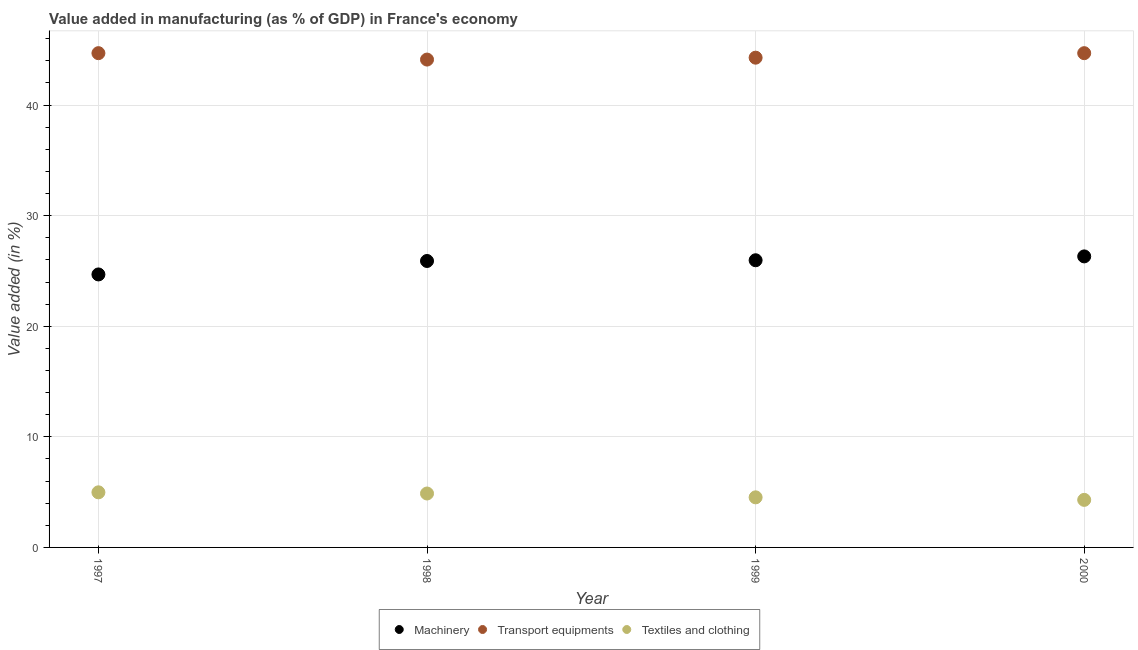How many different coloured dotlines are there?
Your answer should be very brief. 3. Is the number of dotlines equal to the number of legend labels?
Provide a short and direct response. Yes. What is the value added in manufacturing textile and clothing in 1997?
Ensure brevity in your answer.  4.98. Across all years, what is the maximum value added in manufacturing textile and clothing?
Provide a short and direct response. 4.98. Across all years, what is the minimum value added in manufacturing transport equipments?
Provide a succinct answer. 44.12. In which year was the value added in manufacturing textile and clothing maximum?
Keep it short and to the point. 1997. In which year was the value added in manufacturing machinery minimum?
Keep it short and to the point. 1997. What is the total value added in manufacturing textile and clothing in the graph?
Offer a very short reply. 18.69. What is the difference between the value added in manufacturing transport equipments in 1997 and that in 1998?
Make the answer very short. 0.58. What is the difference between the value added in manufacturing transport equipments in 1998 and the value added in manufacturing machinery in 2000?
Provide a short and direct response. 17.8. What is the average value added in manufacturing machinery per year?
Your answer should be very brief. 25.72. In the year 1999, what is the difference between the value added in manufacturing transport equipments and value added in manufacturing textile and clothing?
Give a very brief answer. 39.76. What is the ratio of the value added in manufacturing textile and clothing in 1997 to that in 2000?
Offer a terse response. 1.16. Is the difference between the value added in manufacturing machinery in 1999 and 2000 greater than the difference between the value added in manufacturing textile and clothing in 1999 and 2000?
Provide a short and direct response. No. What is the difference between the highest and the second highest value added in manufacturing textile and clothing?
Offer a terse response. 0.11. What is the difference between the highest and the lowest value added in manufacturing textile and clothing?
Keep it short and to the point. 0.68. In how many years, is the value added in manufacturing transport equipments greater than the average value added in manufacturing transport equipments taken over all years?
Keep it short and to the point. 2. Is the sum of the value added in manufacturing transport equipments in 1998 and 1999 greater than the maximum value added in manufacturing textile and clothing across all years?
Your response must be concise. Yes. Does the value added in manufacturing transport equipments monotonically increase over the years?
Make the answer very short. No. Is the value added in manufacturing machinery strictly greater than the value added in manufacturing transport equipments over the years?
Ensure brevity in your answer.  No. How many dotlines are there?
Give a very brief answer. 3. How many years are there in the graph?
Offer a very short reply. 4. What is the difference between two consecutive major ticks on the Y-axis?
Ensure brevity in your answer.  10. How are the legend labels stacked?
Your answer should be very brief. Horizontal. What is the title of the graph?
Provide a succinct answer. Value added in manufacturing (as % of GDP) in France's economy. What is the label or title of the X-axis?
Provide a short and direct response. Year. What is the label or title of the Y-axis?
Keep it short and to the point. Value added (in %). What is the Value added (in %) in Machinery in 1997?
Your answer should be compact. 24.69. What is the Value added (in %) of Transport equipments in 1997?
Ensure brevity in your answer.  44.7. What is the Value added (in %) of Textiles and clothing in 1997?
Keep it short and to the point. 4.98. What is the Value added (in %) in Machinery in 1998?
Give a very brief answer. 25.9. What is the Value added (in %) in Transport equipments in 1998?
Provide a short and direct response. 44.12. What is the Value added (in %) of Textiles and clothing in 1998?
Give a very brief answer. 4.88. What is the Value added (in %) in Machinery in 1999?
Your response must be concise. 25.97. What is the Value added (in %) in Transport equipments in 1999?
Provide a short and direct response. 44.29. What is the Value added (in %) in Textiles and clothing in 1999?
Your answer should be compact. 4.53. What is the Value added (in %) in Machinery in 2000?
Provide a succinct answer. 26.32. What is the Value added (in %) of Transport equipments in 2000?
Provide a short and direct response. 44.7. What is the Value added (in %) in Textiles and clothing in 2000?
Provide a short and direct response. 4.3. Across all years, what is the maximum Value added (in %) of Machinery?
Your answer should be very brief. 26.32. Across all years, what is the maximum Value added (in %) in Transport equipments?
Offer a terse response. 44.7. Across all years, what is the maximum Value added (in %) in Textiles and clothing?
Offer a terse response. 4.98. Across all years, what is the minimum Value added (in %) of Machinery?
Your answer should be compact. 24.69. Across all years, what is the minimum Value added (in %) in Transport equipments?
Ensure brevity in your answer.  44.12. Across all years, what is the minimum Value added (in %) of Textiles and clothing?
Make the answer very short. 4.3. What is the total Value added (in %) in Machinery in the graph?
Your answer should be compact. 102.88. What is the total Value added (in %) in Transport equipments in the graph?
Provide a short and direct response. 177.8. What is the total Value added (in %) of Textiles and clothing in the graph?
Your answer should be compact. 18.69. What is the difference between the Value added (in %) in Machinery in 1997 and that in 1998?
Offer a terse response. -1.22. What is the difference between the Value added (in %) of Transport equipments in 1997 and that in 1998?
Make the answer very short. 0.58. What is the difference between the Value added (in %) of Textiles and clothing in 1997 and that in 1998?
Offer a very short reply. 0.11. What is the difference between the Value added (in %) in Machinery in 1997 and that in 1999?
Your answer should be very brief. -1.28. What is the difference between the Value added (in %) in Transport equipments in 1997 and that in 1999?
Keep it short and to the point. 0.41. What is the difference between the Value added (in %) of Textiles and clothing in 1997 and that in 1999?
Provide a short and direct response. 0.45. What is the difference between the Value added (in %) in Machinery in 1997 and that in 2000?
Your answer should be compact. -1.63. What is the difference between the Value added (in %) of Transport equipments in 1997 and that in 2000?
Offer a very short reply. 0. What is the difference between the Value added (in %) in Textiles and clothing in 1997 and that in 2000?
Offer a very short reply. 0.68. What is the difference between the Value added (in %) in Machinery in 1998 and that in 1999?
Your answer should be very brief. -0.07. What is the difference between the Value added (in %) in Transport equipments in 1998 and that in 1999?
Provide a short and direct response. -0.17. What is the difference between the Value added (in %) in Textiles and clothing in 1998 and that in 1999?
Your answer should be very brief. 0.35. What is the difference between the Value added (in %) in Machinery in 1998 and that in 2000?
Offer a terse response. -0.41. What is the difference between the Value added (in %) in Transport equipments in 1998 and that in 2000?
Ensure brevity in your answer.  -0.58. What is the difference between the Value added (in %) in Textiles and clothing in 1998 and that in 2000?
Offer a terse response. 0.58. What is the difference between the Value added (in %) in Machinery in 1999 and that in 2000?
Ensure brevity in your answer.  -0.35. What is the difference between the Value added (in %) of Transport equipments in 1999 and that in 2000?
Your response must be concise. -0.41. What is the difference between the Value added (in %) in Textiles and clothing in 1999 and that in 2000?
Keep it short and to the point. 0.23. What is the difference between the Value added (in %) of Machinery in 1997 and the Value added (in %) of Transport equipments in 1998?
Keep it short and to the point. -19.43. What is the difference between the Value added (in %) of Machinery in 1997 and the Value added (in %) of Textiles and clothing in 1998?
Make the answer very short. 19.81. What is the difference between the Value added (in %) of Transport equipments in 1997 and the Value added (in %) of Textiles and clothing in 1998?
Ensure brevity in your answer.  39.82. What is the difference between the Value added (in %) in Machinery in 1997 and the Value added (in %) in Transport equipments in 1999?
Offer a terse response. -19.6. What is the difference between the Value added (in %) in Machinery in 1997 and the Value added (in %) in Textiles and clothing in 1999?
Your response must be concise. 20.16. What is the difference between the Value added (in %) in Transport equipments in 1997 and the Value added (in %) in Textiles and clothing in 1999?
Your response must be concise. 40.17. What is the difference between the Value added (in %) of Machinery in 1997 and the Value added (in %) of Transport equipments in 2000?
Offer a terse response. -20.01. What is the difference between the Value added (in %) of Machinery in 1997 and the Value added (in %) of Textiles and clothing in 2000?
Keep it short and to the point. 20.39. What is the difference between the Value added (in %) in Transport equipments in 1997 and the Value added (in %) in Textiles and clothing in 2000?
Provide a short and direct response. 40.4. What is the difference between the Value added (in %) of Machinery in 1998 and the Value added (in %) of Transport equipments in 1999?
Keep it short and to the point. -18.39. What is the difference between the Value added (in %) of Machinery in 1998 and the Value added (in %) of Textiles and clothing in 1999?
Give a very brief answer. 21.37. What is the difference between the Value added (in %) of Transport equipments in 1998 and the Value added (in %) of Textiles and clothing in 1999?
Provide a short and direct response. 39.59. What is the difference between the Value added (in %) of Machinery in 1998 and the Value added (in %) of Transport equipments in 2000?
Your answer should be compact. -18.79. What is the difference between the Value added (in %) of Machinery in 1998 and the Value added (in %) of Textiles and clothing in 2000?
Give a very brief answer. 21.6. What is the difference between the Value added (in %) of Transport equipments in 1998 and the Value added (in %) of Textiles and clothing in 2000?
Give a very brief answer. 39.82. What is the difference between the Value added (in %) of Machinery in 1999 and the Value added (in %) of Transport equipments in 2000?
Offer a terse response. -18.73. What is the difference between the Value added (in %) of Machinery in 1999 and the Value added (in %) of Textiles and clothing in 2000?
Provide a succinct answer. 21.67. What is the difference between the Value added (in %) of Transport equipments in 1999 and the Value added (in %) of Textiles and clothing in 2000?
Provide a short and direct response. 39.99. What is the average Value added (in %) in Machinery per year?
Provide a short and direct response. 25.72. What is the average Value added (in %) of Transport equipments per year?
Provide a succinct answer. 44.45. What is the average Value added (in %) of Textiles and clothing per year?
Keep it short and to the point. 4.67. In the year 1997, what is the difference between the Value added (in %) in Machinery and Value added (in %) in Transport equipments?
Your answer should be very brief. -20.01. In the year 1997, what is the difference between the Value added (in %) in Machinery and Value added (in %) in Textiles and clothing?
Ensure brevity in your answer.  19.7. In the year 1997, what is the difference between the Value added (in %) in Transport equipments and Value added (in %) in Textiles and clothing?
Ensure brevity in your answer.  39.71. In the year 1998, what is the difference between the Value added (in %) in Machinery and Value added (in %) in Transport equipments?
Give a very brief answer. -18.21. In the year 1998, what is the difference between the Value added (in %) of Machinery and Value added (in %) of Textiles and clothing?
Give a very brief answer. 21.03. In the year 1998, what is the difference between the Value added (in %) in Transport equipments and Value added (in %) in Textiles and clothing?
Provide a short and direct response. 39.24. In the year 1999, what is the difference between the Value added (in %) of Machinery and Value added (in %) of Transport equipments?
Give a very brief answer. -18.32. In the year 1999, what is the difference between the Value added (in %) of Machinery and Value added (in %) of Textiles and clothing?
Offer a very short reply. 21.44. In the year 1999, what is the difference between the Value added (in %) in Transport equipments and Value added (in %) in Textiles and clothing?
Provide a short and direct response. 39.76. In the year 2000, what is the difference between the Value added (in %) in Machinery and Value added (in %) in Transport equipments?
Give a very brief answer. -18.38. In the year 2000, what is the difference between the Value added (in %) of Machinery and Value added (in %) of Textiles and clothing?
Provide a short and direct response. 22.02. In the year 2000, what is the difference between the Value added (in %) in Transport equipments and Value added (in %) in Textiles and clothing?
Keep it short and to the point. 40.4. What is the ratio of the Value added (in %) in Machinery in 1997 to that in 1998?
Offer a terse response. 0.95. What is the ratio of the Value added (in %) in Transport equipments in 1997 to that in 1998?
Offer a terse response. 1.01. What is the ratio of the Value added (in %) of Textiles and clothing in 1997 to that in 1998?
Offer a very short reply. 1.02. What is the ratio of the Value added (in %) in Machinery in 1997 to that in 1999?
Make the answer very short. 0.95. What is the ratio of the Value added (in %) of Transport equipments in 1997 to that in 1999?
Provide a succinct answer. 1.01. What is the ratio of the Value added (in %) of Textiles and clothing in 1997 to that in 1999?
Offer a terse response. 1.1. What is the ratio of the Value added (in %) of Machinery in 1997 to that in 2000?
Your answer should be very brief. 0.94. What is the ratio of the Value added (in %) in Transport equipments in 1997 to that in 2000?
Your answer should be compact. 1. What is the ratio of the Value added (in %) in Textiles and clothing in 1997 to that in 2000?
Your response must be concise. 1.16. What is the ratio of the Value added (in %) in Transport equipments in 1998 to that in 1999?
Provide a succinct answer. 1. What is the ratio of the Value added (in %) in Textiles and clothing in 1998 to that in 1999?
Offer a very short reply. 1.08. What is the ratio of the Value added (in %) in Machinery in 1998 to that in 2000?
Your answer should be compact. 0.98. What is the ratio of the Value added (in %) of Transport equipments in 1998 to that in 2000?
Keep it short and to the point. 0.99. What is the ratio of the Value added (in %) in Textiles and clothing in 1998 to that in 2000?
Your answer should be compact. 1.13. What is the ratio of the Value added (in %) in Machinery in 1999 to that in 2000?
Offer a very short reply. 0.99. What is the ratio of the Value added (in %) of Transport equipments in 1999 to that in 2000?
Offer a very short reply. 0.99. What is the ratio of the Value added (in %) in Textiles and clothing in 1999 to that in 2000?
Ensure brevity in your answer.  1.05. What is the difference between the highest and the second highest Value added (in %) in Machinery?
Your answer should be compact. 0.35. What is the difference between the highest and the second highest Value added (in %) of Transport equipments?
Keep it short and to the point. 0. What is the difference between the highest and the second highest Value added (in %) of Textiles and clothing?
Your answer should be compact. 0.11. What is the difference between the highest and the lowest Value added (in %) in Machinery?
Your response must be concise. 1.63. What is the difference between the highest and the lowest Value added (in %) in Transport equipments?
Keep it short and to the point. 0.58. What is the difference between the highest and the lowest Value added (in %) of Textiles and clothing?
Offer a very short reply. 0.68. 